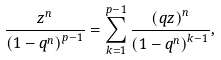<formula> <loc_0><loc_0><loc_500><loc_500>\frac { z ^ { n } } { \left ( 1 - q ^ { n } \right ) ^ { p - 1 } } = \sum _ { k = 1 } ^ { p - 1 } \frac { \left ( q z \right ) ^ { n } } { \left ( 1 - q ^ { n } \right ) ^ { k - 1 } } ,</formula> 